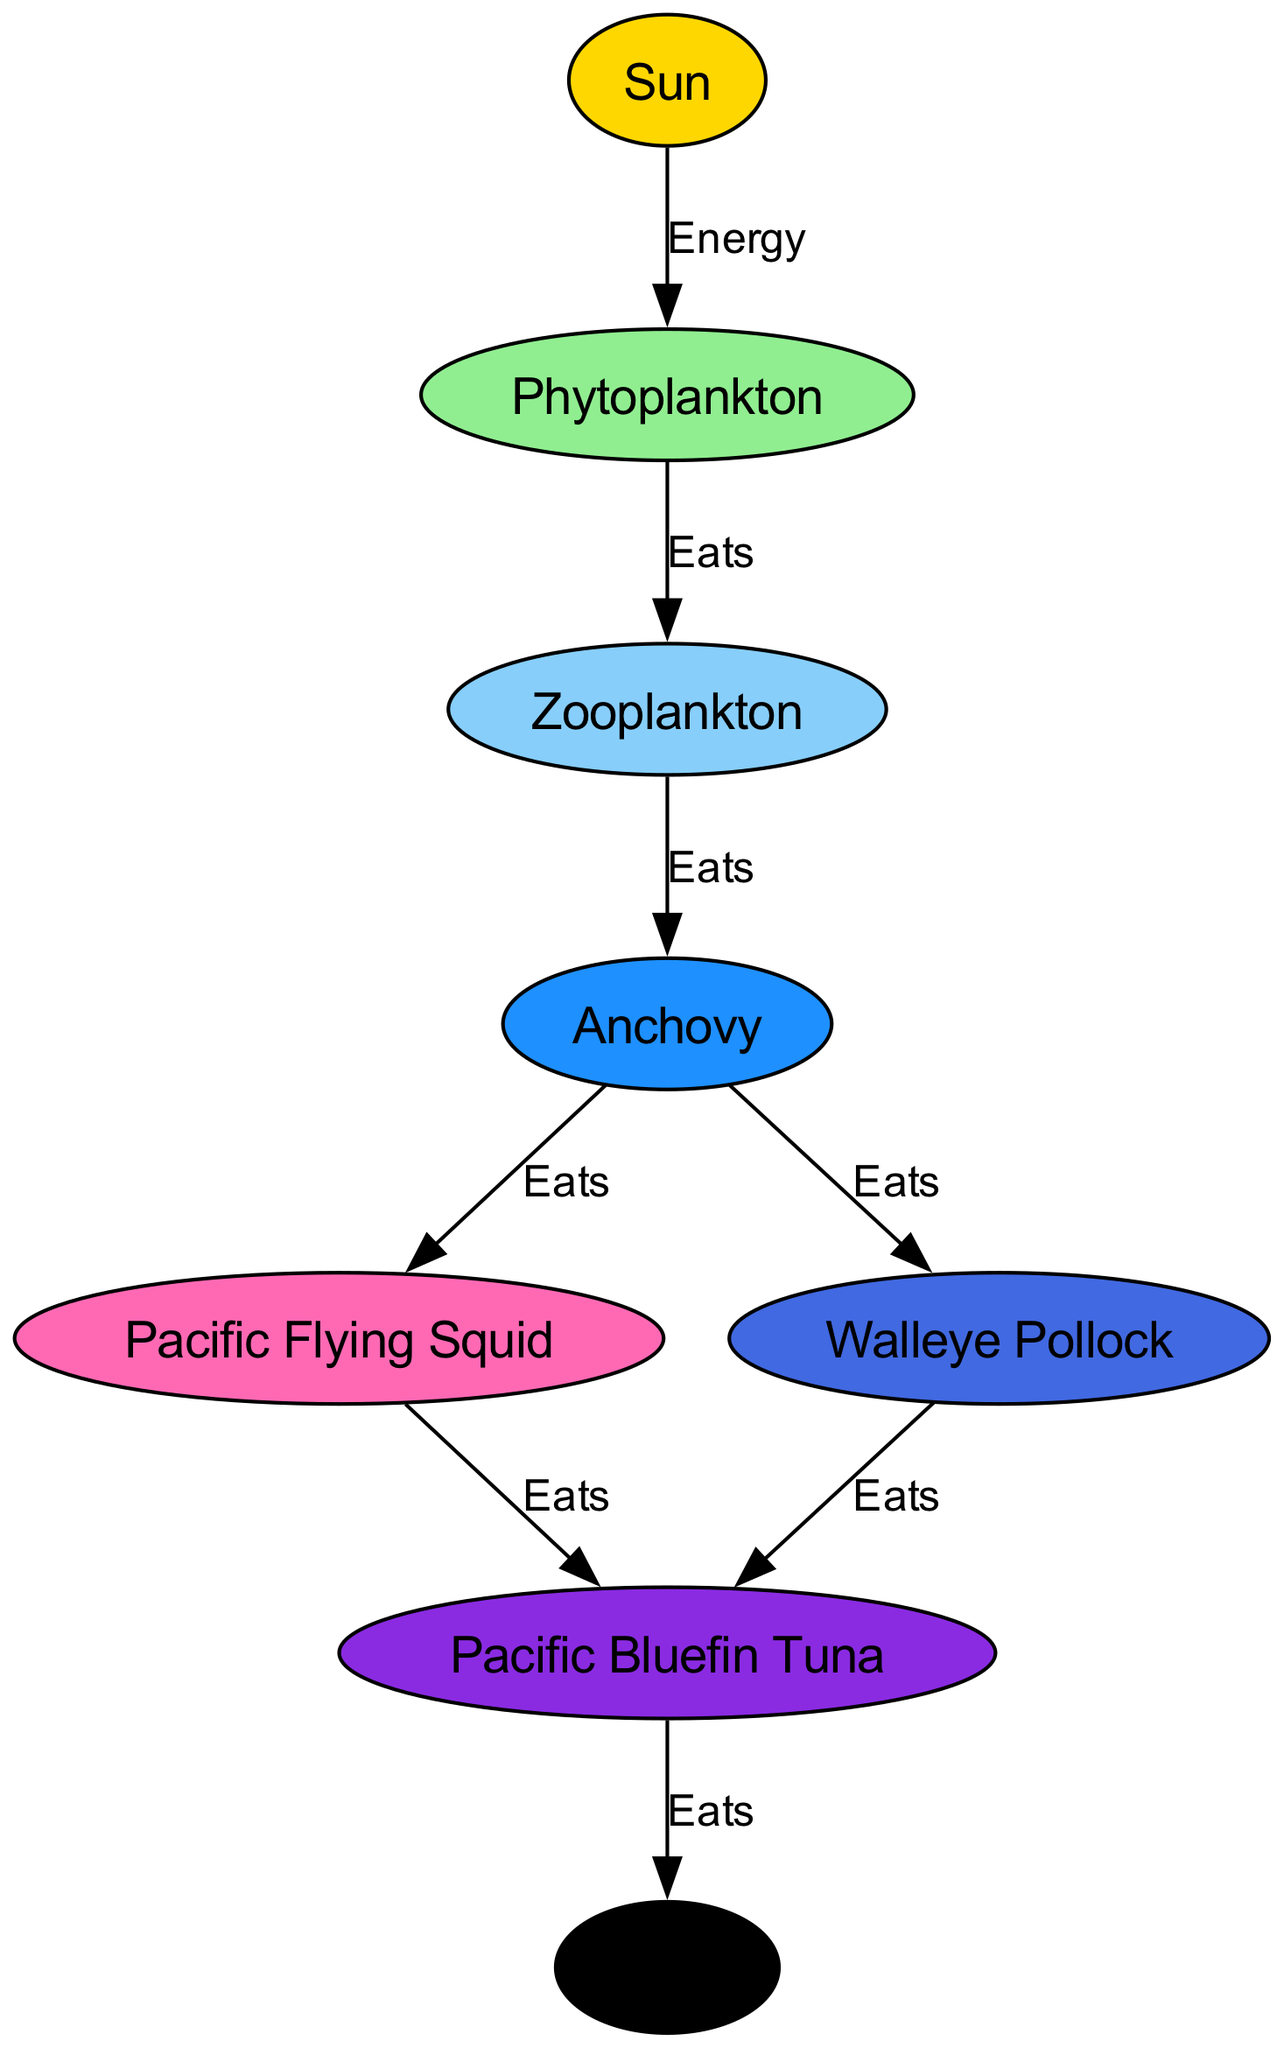What is the first node in the food chain? The first node, which is the source of energy in the food chain, is labeled "Sun." It is responsible for providing energy to phytoplankton.
Answer: Sun How many levels are there in the marine food chain? The food chain consists of a total of 8 nodes. They include the Sun, phytoplankton, zooplankton, anchovy, squid, pollock, tuna, and orca, indicating 8 distinct levels.
Answer: 8 What do phytoplankton eat? In the food chain, phytoplankton are consumed by zooplankton, which is indicated by the "Eats" label connecting them.
Answer: Zooplankton Which organism is at the top of the food chain? The top of the food chain, representing the final predator in this marine ecosystem, is labeled "Orca." It signifies that the orca has no natural predators in this diagram.
Answer: Orca How many species can eat anchovy? In the diagram, anchovy is eaten by both squid and pollock. This indicates that there are 2 species that can consume anchovy.
Answer: 2 What is the relationship between tuna and orca? The relationship indicates that tuna is a prey to orca, shown by the "Eats" label connecting the two in the food chain.
Answer: Eats Which organisms share the same prey? Both squid and pollock share the same prey, which is tuna. This is notable from the direct connection of both species eating tuna in the food chain.
Answer: Tuna What is the color representing phytoplankton? In the diagram, phytoplankton are represented in a light green color, which is designated by its specific color code in the visual representation.
Answer: Light green 